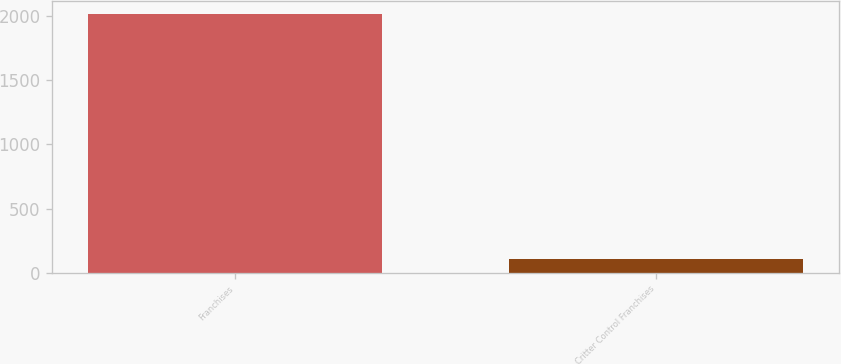<chart> <loc_0><loc_0><loc_500><loc_500><bar_chart><fcel>Franchises<fcel>Critter Control Franchises<nl><fcel>2015<fcel>108<nl></chart> 